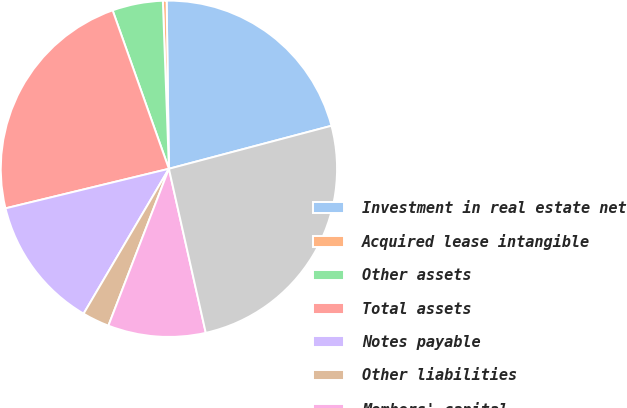Convert chart. <chart><loc_0><loc_0><loc_500><loc_500><pie_chart><fcel>Investment in real estate net<fcel>Acquired lease intangible<fcel>Other assets<fcel>Total assets<fcel>Notes payable<fcel>Other liabilities<fcel>Members' capital<fcel>Total liabilities and equity<nl><fcel>21.1%<fcel>0.36%<fcel>4.86%<fcel>23.35%<fcel>12.75%<fcel>2.61%<fcel>9.38%<fcel>25.6%<nl></chart> 